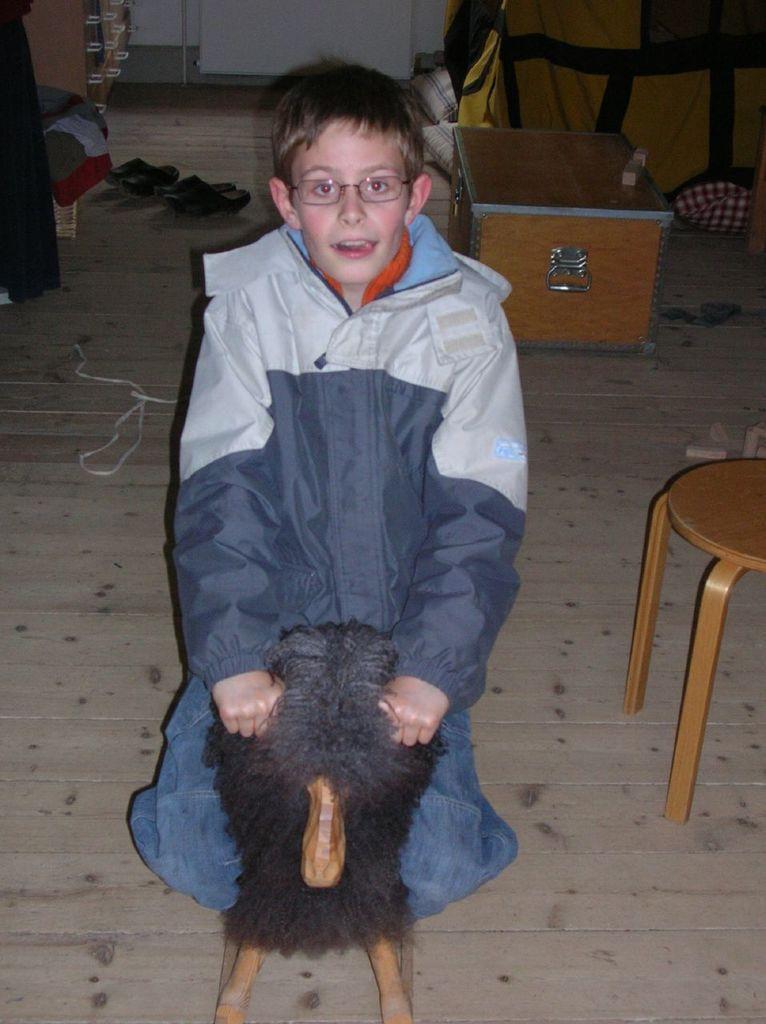How would you summarize this image in a sentence or two? In this picture there is a boy who is sitting on a toy horse at the center of the image, there is a box behind the boy and there is a stool at the right side of the image and two pair of shoes at the left side of the image. 